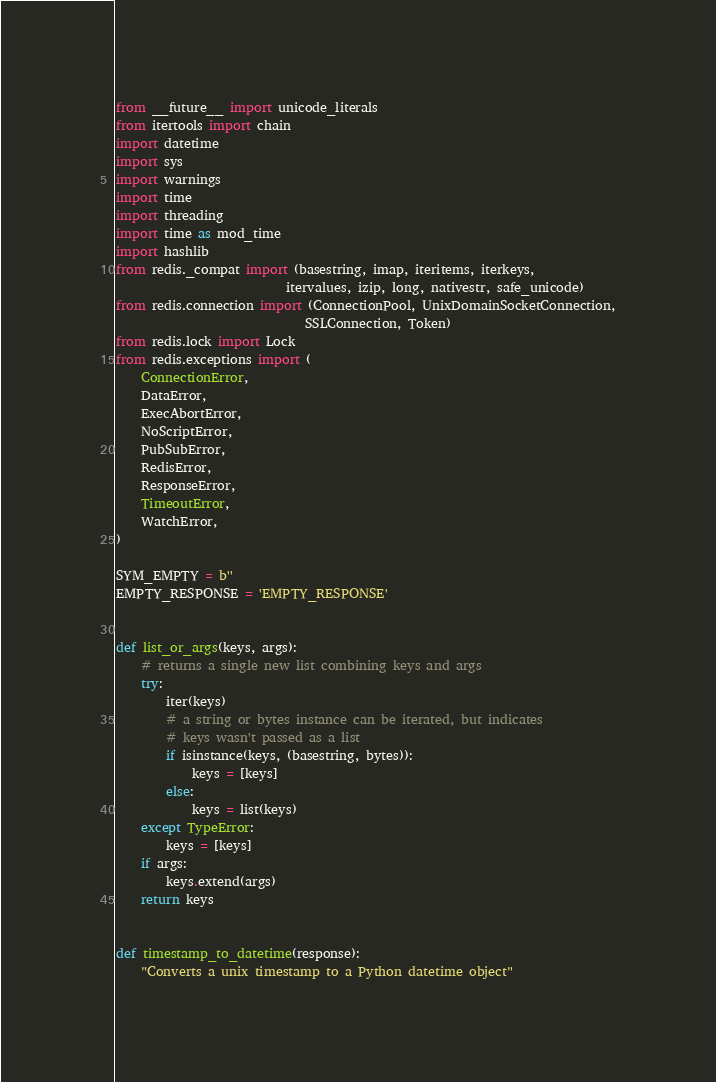Convert code to text. <code><loc_0><loc_0><loc_500><loc_500><_Python_>from __future__ import unicode_literals
from itertools import chain
import datetime
import sys
import warnings
import time
import threading
import time as mod_time
import hashlib
from redis._compat import (basestring, imap, iteritems, iterkeys,
                           itervalues, izip, long, nativestr, safe_unicode)
from redis.connection import (ConnectionPool, UnixDomainSocketConnection,
                              SSLConnection, Token)
from redis.lock import Lock
from redis.exceptions import (
    ConnectionError,
    DataError,
    ExecAbortError,
    NoScriptError,
    PubSubError,
    RedisError,
    ResponseError,
    TimeoutError,
    WatchError,
)

SYM_EMPTY = b''
EMPTY_RESPONSE = 'EMPTY_RESPONSE'


def list_or_args(keys, args):
    # returns a single new list combining keys and args
    try:
        iter(keys)
        # a string or bytes instance can be iterated, but indicates
        # keys wasn't passed as a list
        if isinstance(keys, (basestring, bytes)):
            keys = [keys]
        else:
            keys = list(keys)
    except TypeError:
        keys = [keys]
    if args:
        keys.extend(args)
    return keys


def timestamp_to_datetime(response):
    "Converts a unix timestamp to a Python datetime object"</code> 